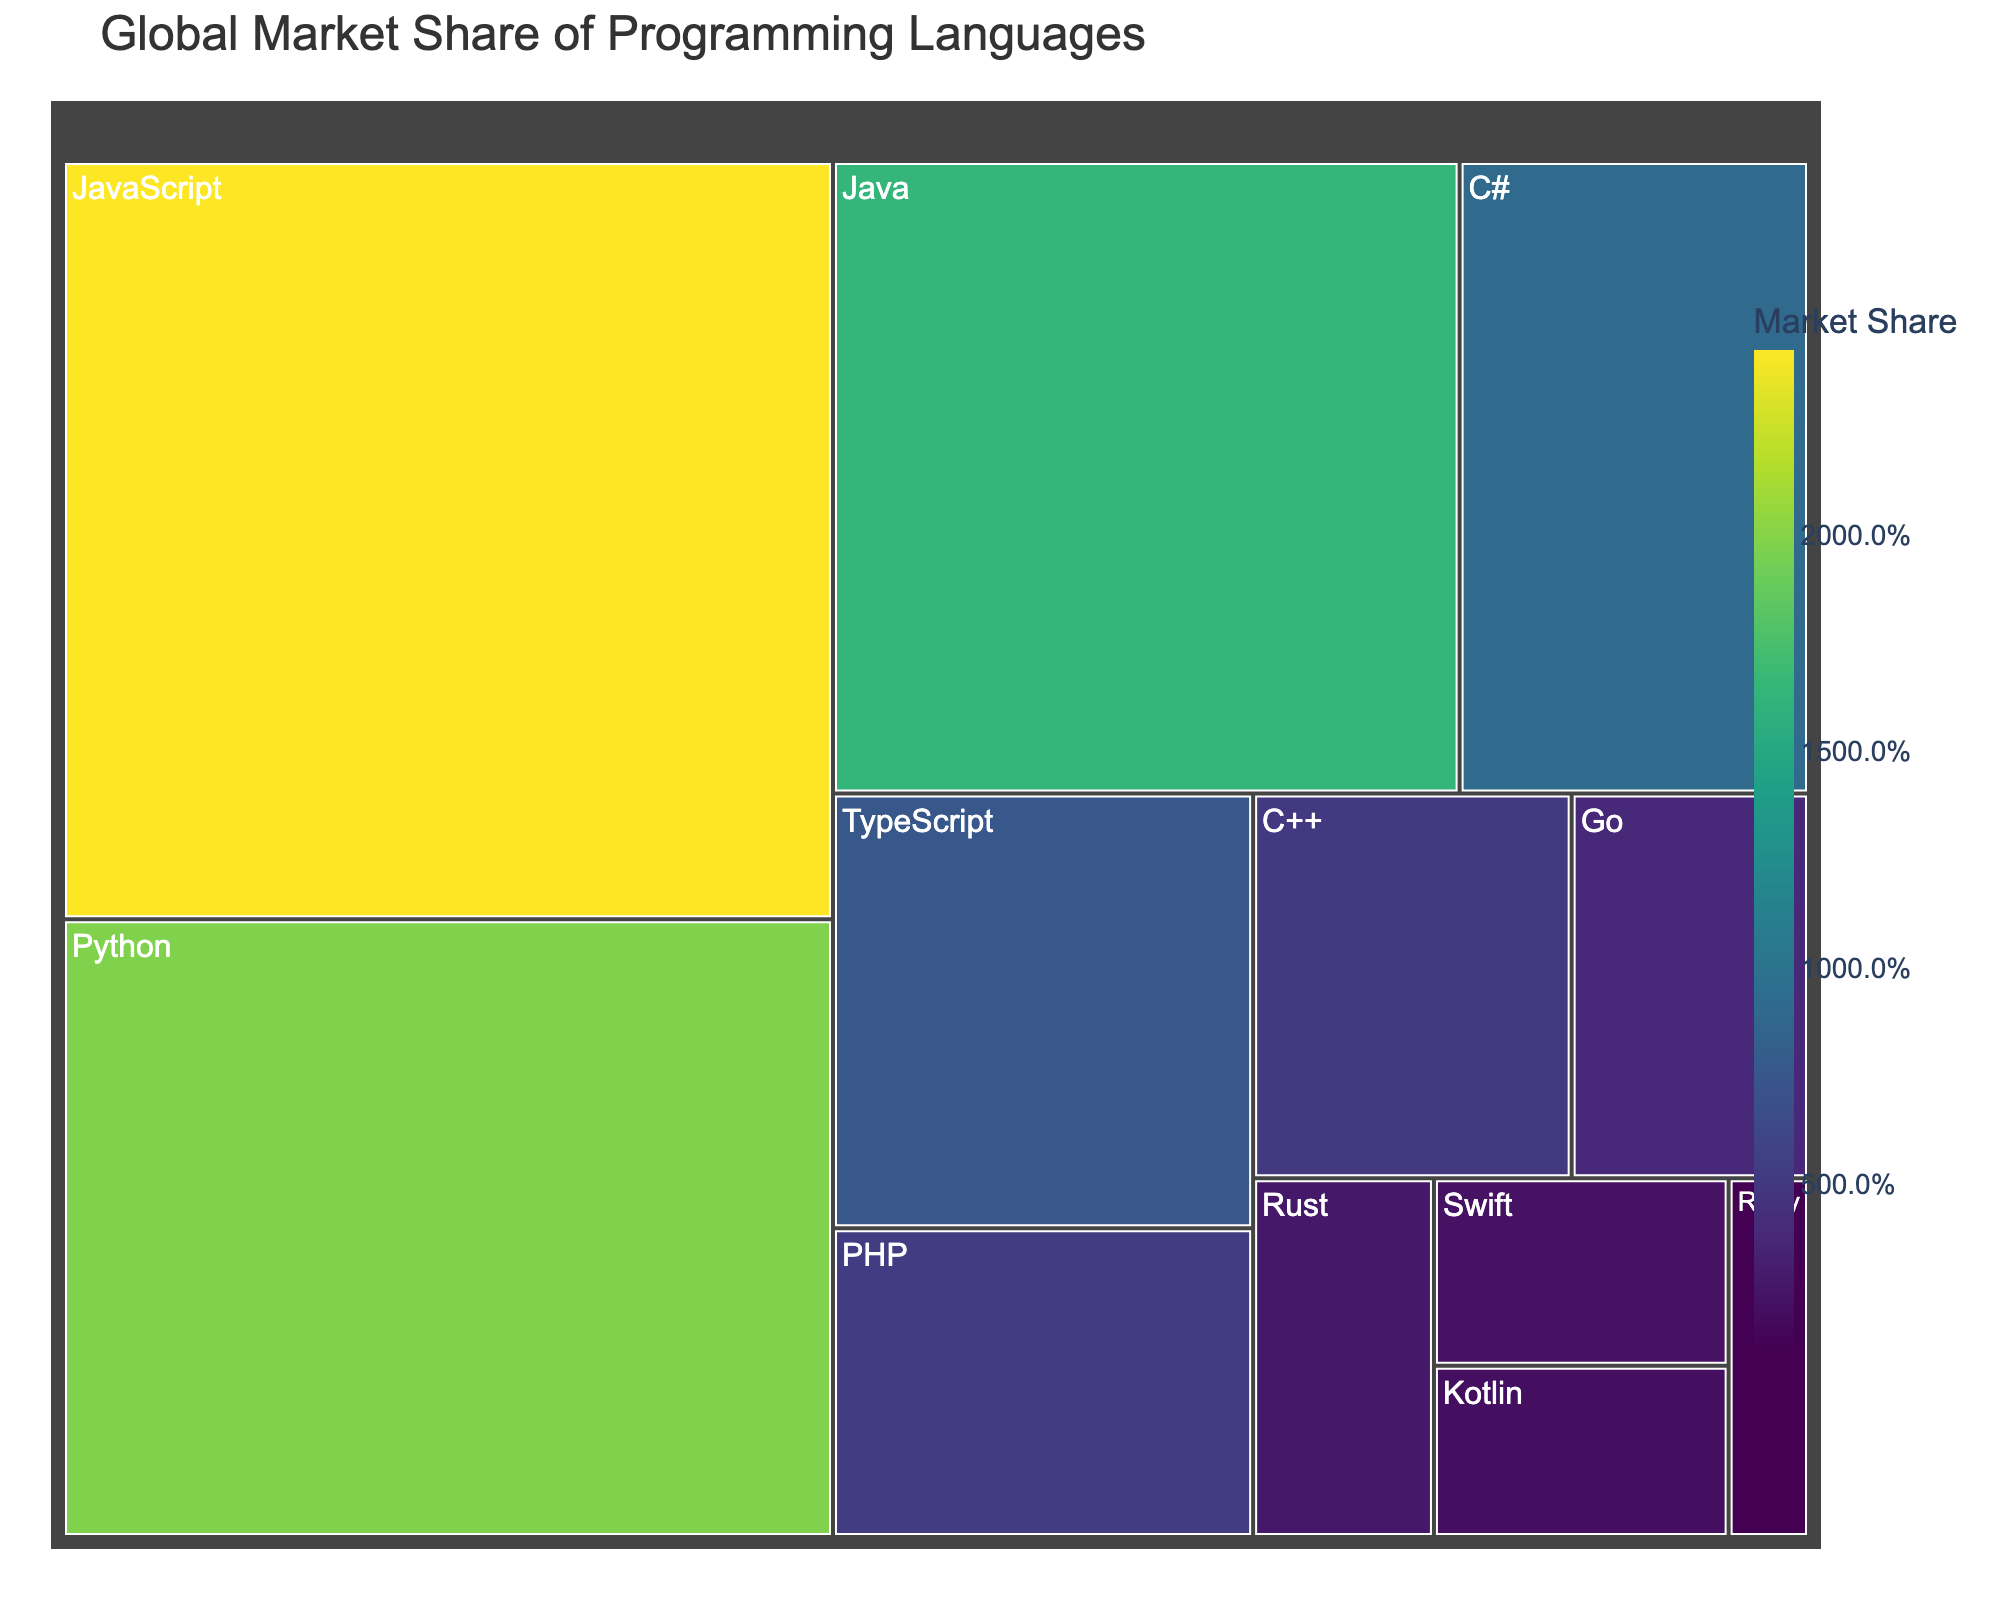Which programming language has the highest global market share? The programming language with the highest market share will be visually the largest section in the Treemap and typically the topmost. Looking at the figure, JavaScript occupies the largest section.
Answer: JavaScript What is the market share of Python? To find the market share of Python, refer to the segment labeled "Python" in the Treemap. The hover data should reveal its market share. According to the data, it is 19.8%.
Answer: 19.8% Which two programming languages have a combined market share of over 40%? Combining market shares involves finding two segments whose combined values exceed 40%. From the data, JavaScript (24.3%) and Python (19.8%) together sum up to 44.1%.
Answer: JavaScript and Python What is the difference in market share between C++ and Go? Identify the market share for both C++ (5.1%) and Go (3.8%). Subtract the smaller value from the larger to find the difference: 5.1 - 3.8 = 1.3.
Answer: 1.3% Which programming language is ranked fifth in terms of market share? To determine the fifth-ranked language, list the languages in descending order of market share. According to the data, JavaScript, Python, Java, C#, and then TypeScript (7.6%) is fifth.
Answer: TypeScript What is the total market share of Java and PHP combined? Sum the market shares of Java (16.5%) and PHP (5.4%) to find their combined value: 16.5 + 5.4 = 21.9.
Answer: 21.9% How many programming languages have a market share below 3%? Count the segments representing languages with market shares less than 3%. According to the data, Rust (2.7%), Swift (2.3%), Kotlin (2.1%), and Ruby (1.2%) meet this criteria, making it four languages.
Answer: 4 Which language shows a market share closest to 10%? Identify the language whose section in the Treemap represents a market share closest to 10%. According to the data, C# has a market share of 9.2%, which is closest to 10%.
Answer: C# What is the lowest market share displayed, and which language does it correspond to? Locate the smallest section in the Treemap, which represents the smallest market share. According to the data, Ruby has the smallest market share at 1.2%.
Answer: Ruby, 1.2% What is the combined market share of the three least popular programming languages? Identify the three languages with the smallest market share: Ruby (1.2%), Kotlin (2.1%), and Swift (2.3%). Sum their market shares: 1.2 + 2.1 + 2.3 = 5.6.
Answer: 5.6% 